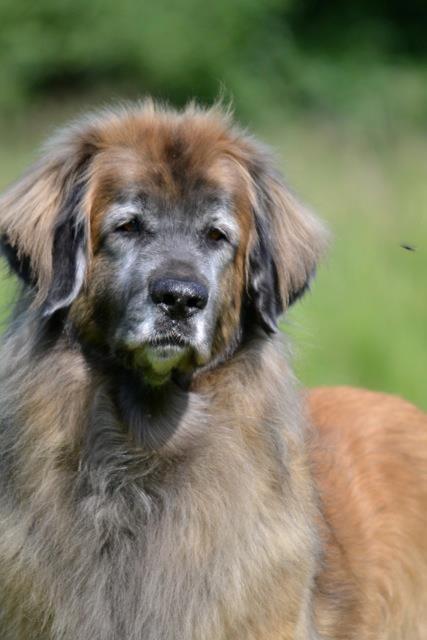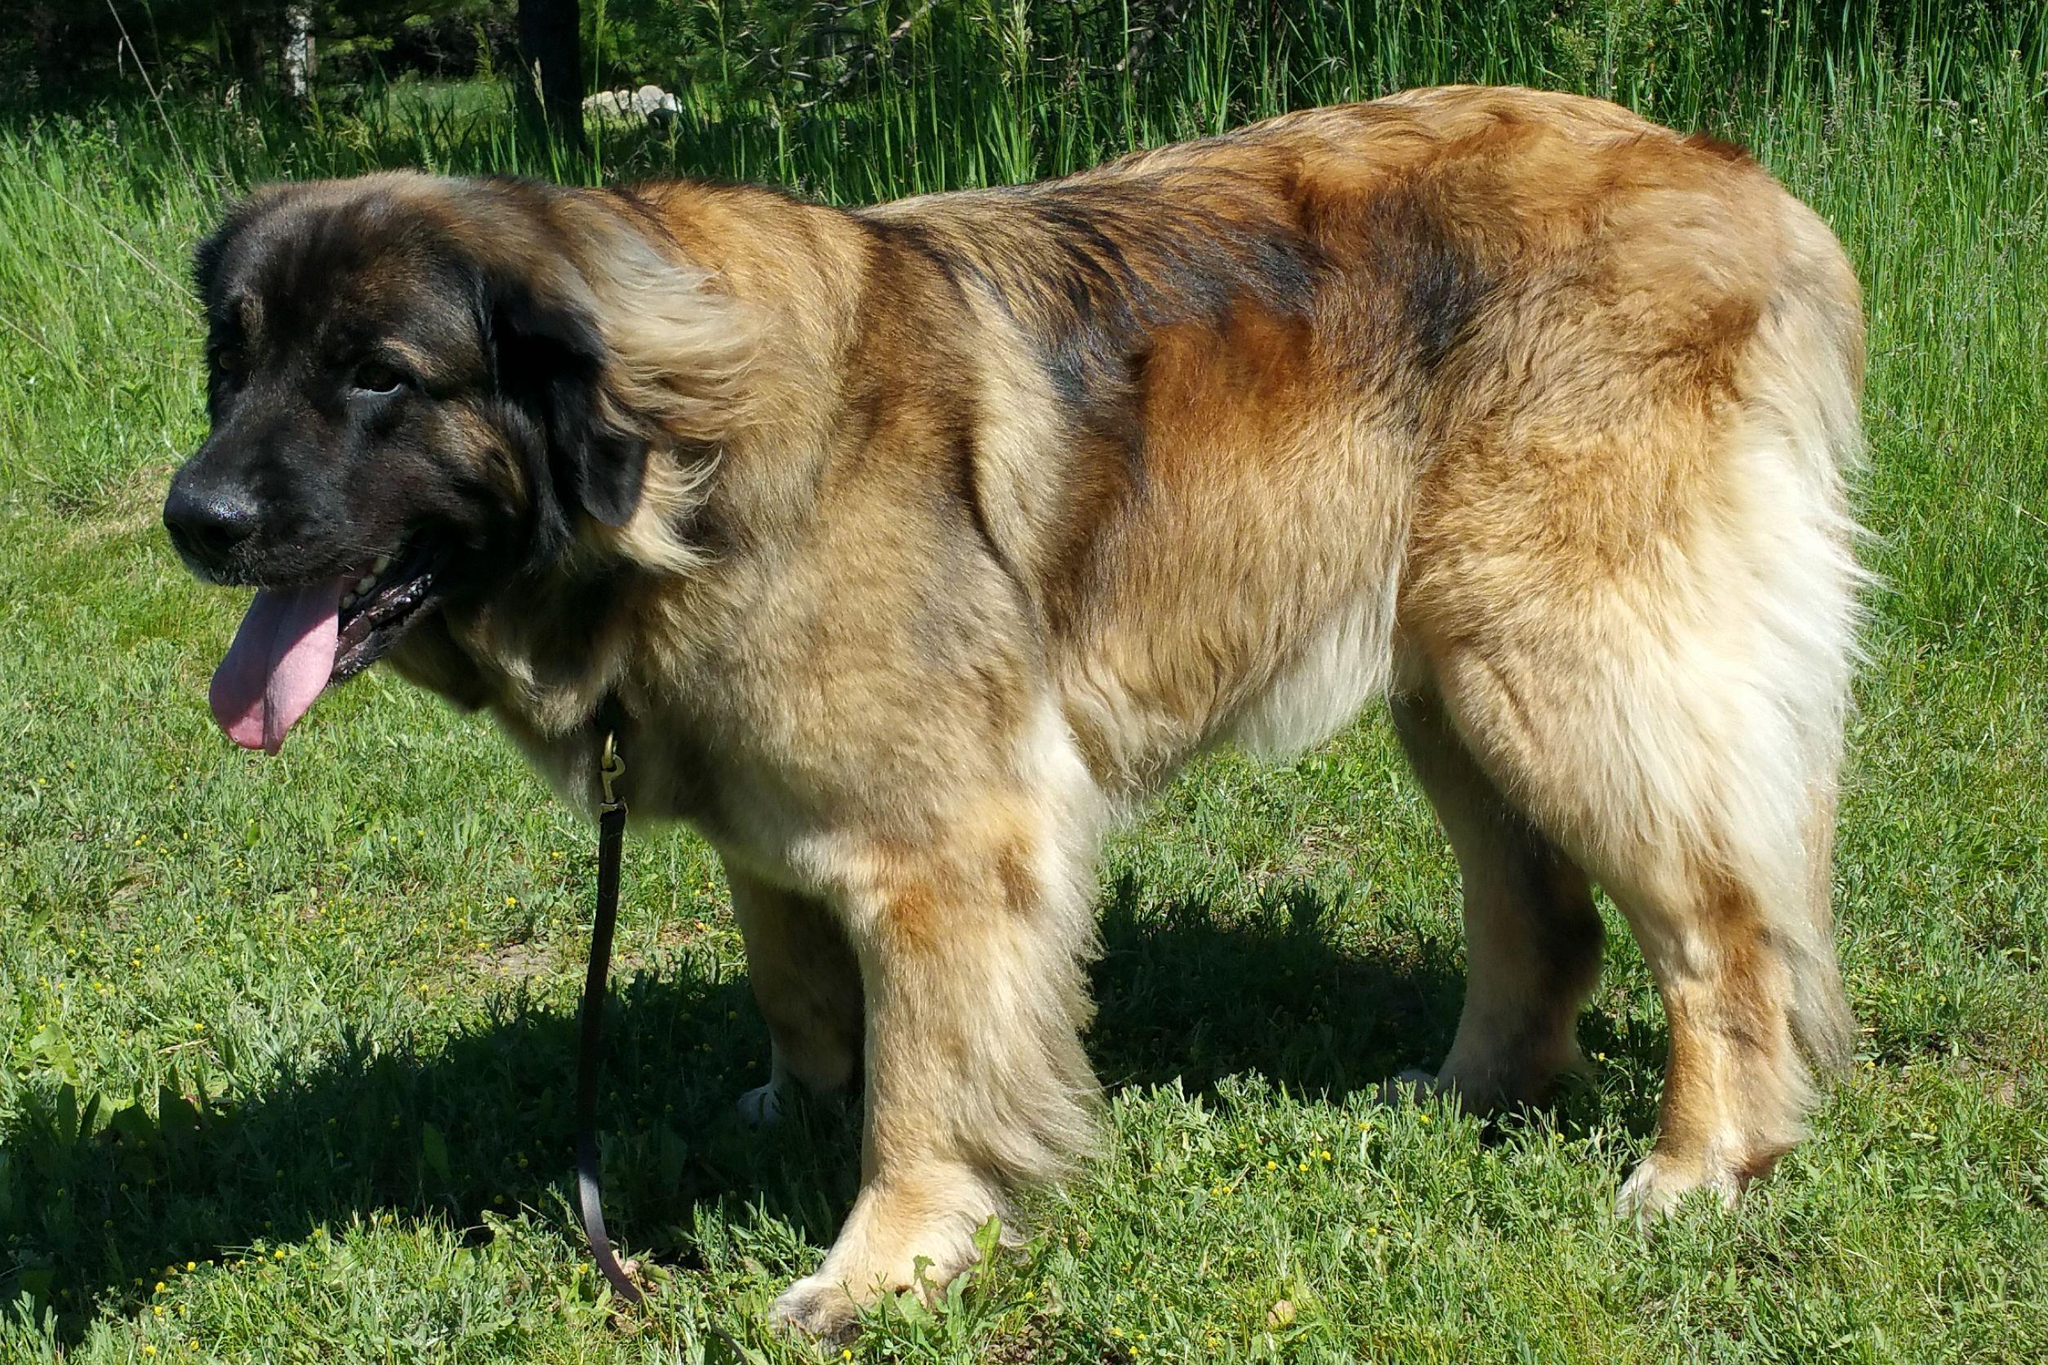The first image is the image on the left, the second image is the image on the right. Assess this claim about the two images: "One image includes a dog standing in profile, and the other image contains at least two dogs.". Correct or not? Answer yes or no. No. The first image is the image on the left, the second image is the image on the right. Assess this claim about the two images: "There are exactly two dogs in the left image.". Correct or not? Answer yes or no. No. 